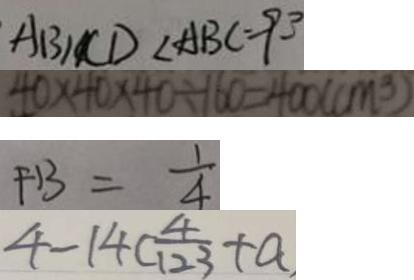Convert formula to latex. <formula><loc_0><loc_0><loc_500><loc_500>A B / / C D < A B C = 9 3 
 4 0 \times 4 0 \times 4 0 \div 1 6 0 = 4 0 0 ( c m ^ { 3 } ) 
 F B = \frac { 1 } { 4 } 
 4 - 1 4 ( \frac { 4 } { 1 2 3 } + a</formula> 